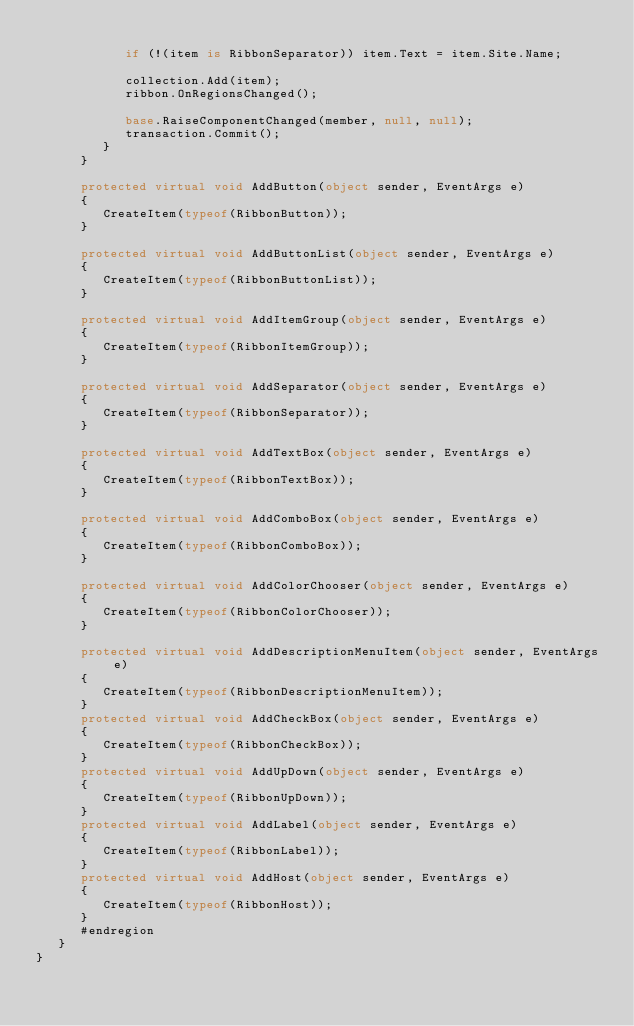<code> <loc_0><loc_0><loc_500><loc_500><_C#_>
            if (!(item is RibbonSeparator)) item.Text = item.Site.Name;

            collection.Add(item);
            ribbon.OnRegionsChanged();

            base.RaiseComponentChanged(member, null, null);
            transaction.Commit();
         }
      }

      protected virtual void AddButton(object sender, EventArgs e)
      {
         CreateItem(typeof(RibbonButton));
      }

      protected virtual void AddButtonList(object sender, EventArgs e)
      {
         CreateItem(typeof(RibbonButtonList));
      }

      protected virtual void AddItemGroup(object sender, EventArgs e)
      {
         CreateItem(typeof(RibbonItemGroup));
      }

      protected virtual void AddSeparator(object sender, EventArgs e)
      {
         CreateItem(typeof(RibbonSeparator));
      }

      protected virtual void AddTextBox(object sender, EventArgs e)
      {
         CreateItem(typeof(RibbonTextBox));
      }

      protected virtual void AddComboBox(object sender, EventArgs e)
      {
         CreateItem(typeof(RibbonComboBox));
      }

      protected virtual void AddColorChooser(object sender, EventArgs e)
      {
         CreateItem(typeof(RibbonColorChooser));
      }

      protected virtual void AddDescriptionMenuItem(object sender, EventArgs e)
      {
         CreateItem(typeof(RibbonDescriptionMenuItem));
      }
      protected virtual void AddCheckBox(object sender, EventArgs e)
      {
         CreateItem(typeof(RibbonCheckBox));
      }
      protected virtual void AddUpDown(object sender, EventArgs e)
      {
         CreateItem(typeof(RibbonUpDown));
      }
      protected virtual void AddLabel(object sender, EventArgs e)
      {
         CreateItem(typeof(RibbonLabel));
      }
      protected virtual void AddHost(object sender, EventArgs e)
      {
         CreateItem(typeof(RibbonHost));
      }
      #endregion
   }
}
</code> 